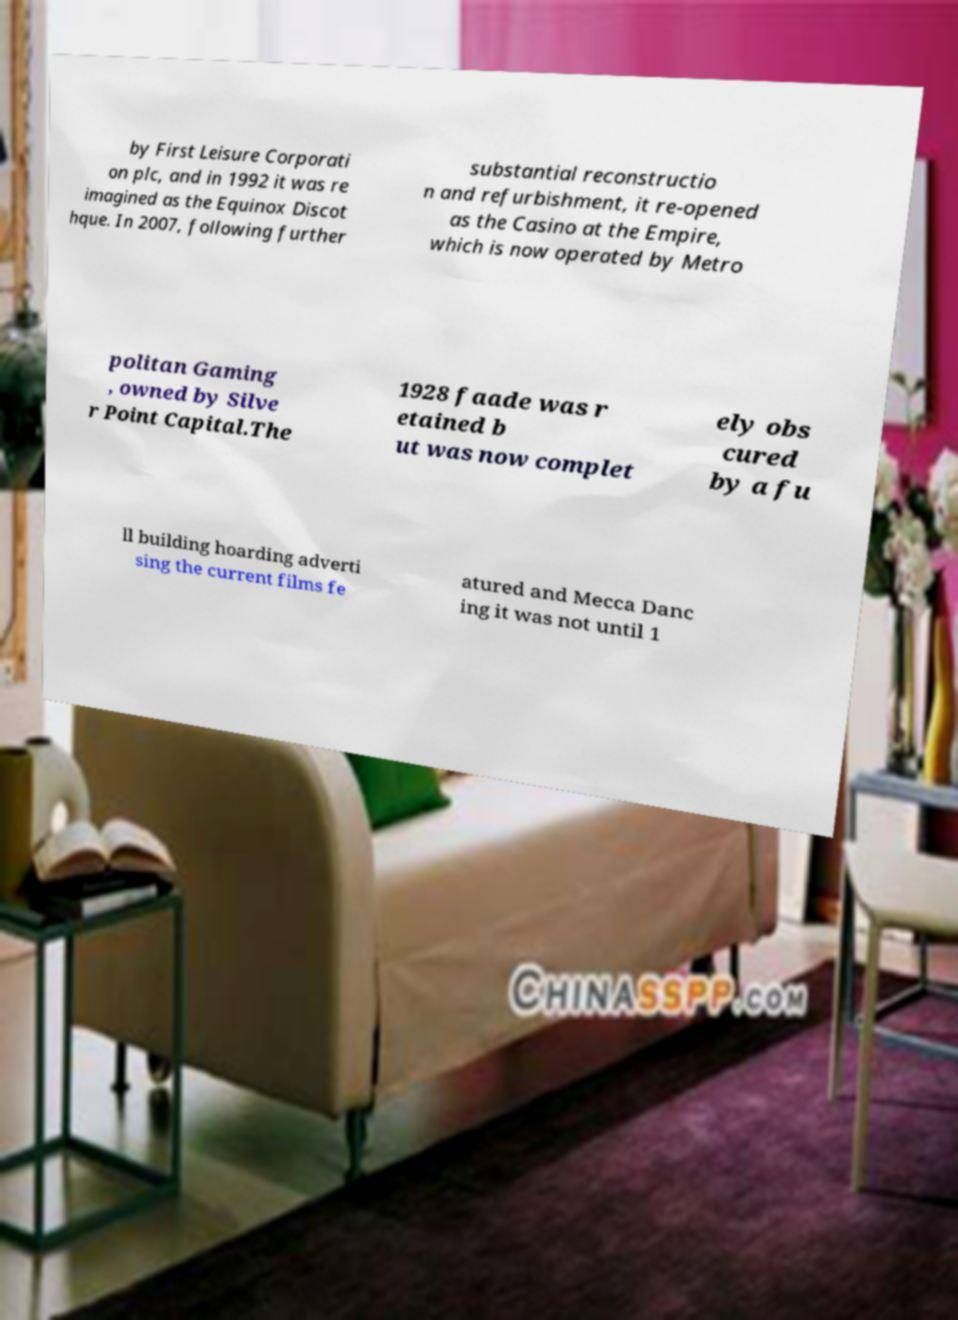There's text embedded in this image that I need extracted. Can you transcribe it verbatim? by First Leisure Corporati on plc, and in 1992 it was re imagined as the Equinox Discot hque. In 2007, following further substantial reconstructio n and refurbishment, it re-opened as the Casino at the Empire, which is now operated by Metro politan Gaming , owned by Silve r Point Capital.The 1928 faade was r etained b ut was now complet ely obs cured by a fu ll building hoarding adverti sing the current films fe atured and Mecca Danc ing it was not until 1 